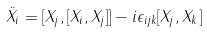Convert formula to latex. <formula><loc_0><loc_0><loc_500><loc_500>\ddot { X } _ { i } = [ X _ { j } , [ X _ { i } , X _ { j } ] ] - i \epsilon _ { i j k } [ X _ { j } , X _ { k } ]</formula> 